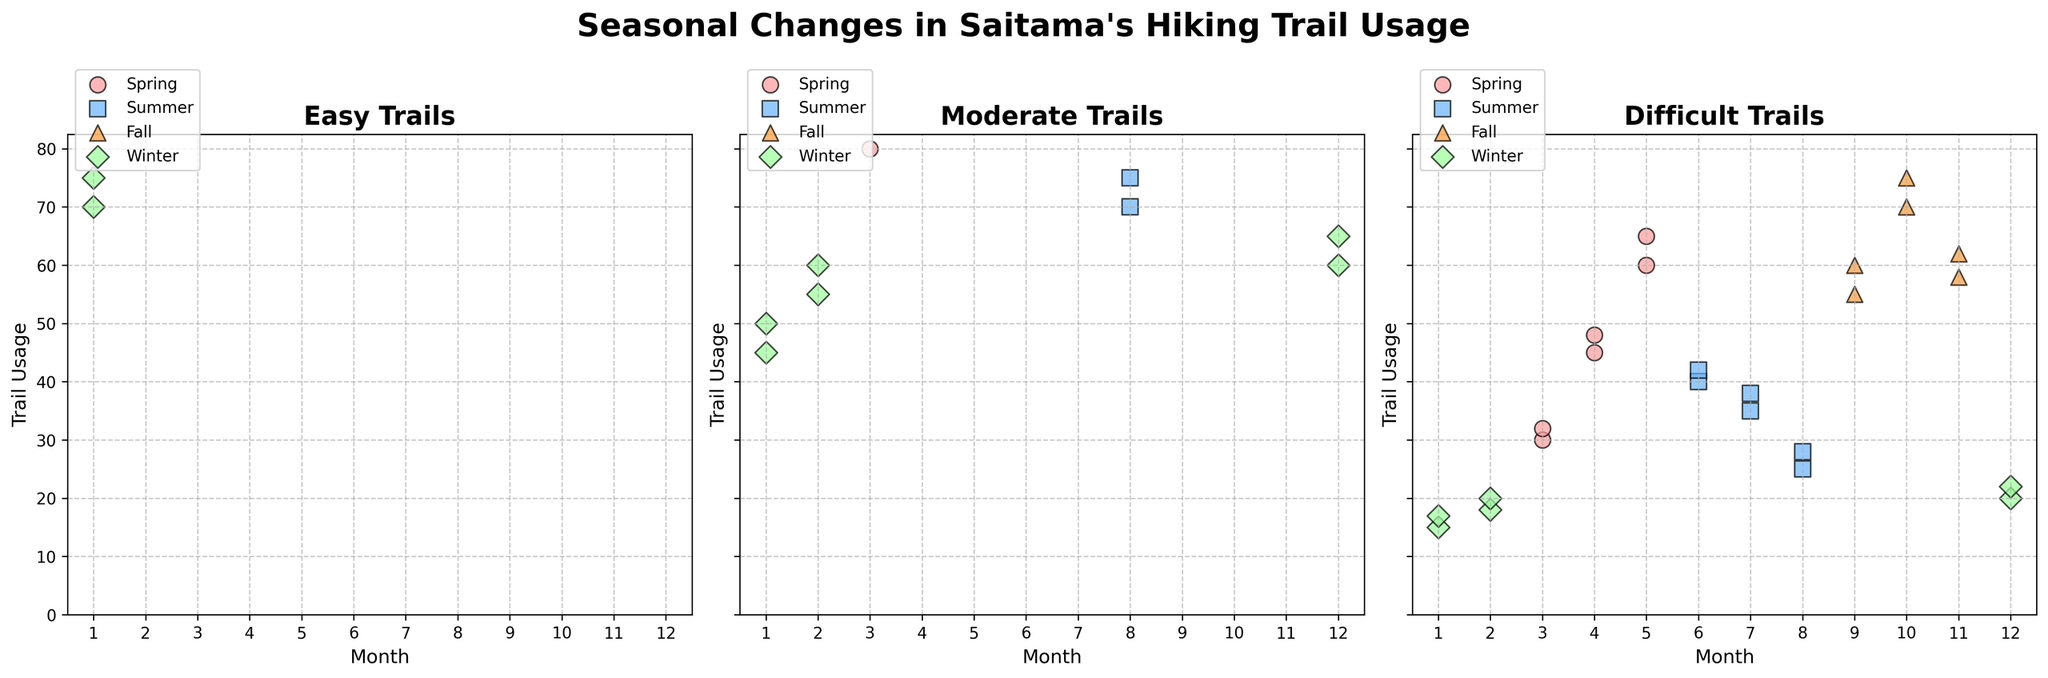What season has the highest usage in Easy Trails? By looking at the scatter plot for Easy Trails, identify the season with the highest data point. Fall months (September, October, November) show the highest usage, especially October.
Answer: Fall Which month has the lowest usage for Difficult Trails? Check the scatter plot for Difficult Trails and identify the month with the lowest data point. January shows the lowest point.
Answer: January In which season do Moderate Trails see the highest usage? Observe the scatter plot for Moderate Trails and determine the season with the highest data points. This is in October during the Fall season.
Answer: Fall Compare the Easy Trail usage between Summer and Winter. Which season has higher usage? Observe the scatter plot for Easy Trails. In general, the scatter plot data points for Summer months (June, July, August) lie higher compared to those for Winter months (December, January, February).
Answer: Summer Which trail difficulty shows the most dramatic seasonal changes in usage? Compare the range of trail usage between different seasons for each trail difficulty. Difficult Trails show the most significant difference between high Fall and low Winter usage.
Answer: Difficult Trails What is the average trail usage for Easy Trails in Spring? Sum the Easy Trail usage for the Spring months (March, April, May) and divide by 3. (120+180+210+130+190+220)/6 = 1050/6
Answer: 175 Does Moderate Trail usage peak in Spring or Fall? Observe the scatter plot for Moderate Trails, focusing on Spring (March, April, May) and Fall (September, October, November). The highest peak is seen in October during the Fall season.
Answer: Fall How does the usage in September across all difficulty levels compare? Check the data points in the scatter plots for all trails in September. September shows high usage for all difficulty levels, particularly Moderate and Difficult Trails.
Answer: High for all Which season shows the most consistent usage across all trail difficulties? Look at how clustered the points are within each season across all subplots. Summer shows relatively consistent usage in all trail difficulties compared to other seasons.
Answer: Summer 